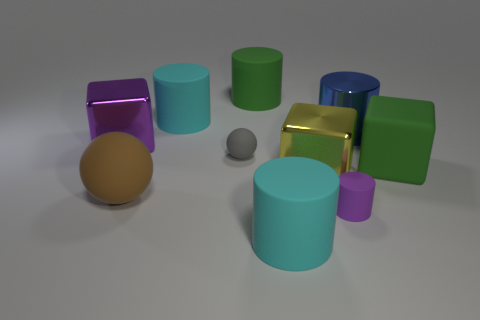Is there any other thing that is the same color as the rubber cube?
Keep it short and to the point. Yes. The purple thing in front of the large matte thing that is on the right side of the purple rubber thing is made of what material?
Provide a succinct answer. Rubber. Is the green cylinder made of the same material as the big blue cylinder behind the large yellow metallic thing?
Offer a terse response. No. How many objects are either big cyan things that are on the right side of the green rubber cylinder or big shiny cubes?
Keep it short and to the point. 3. Is there a big matte cylinder of the same color as the rubber block?
Your response must be concise. Yes. There is a yellow object; does it have the same shape as the big green object that is to the right of the big blue object?
Your response must be concise. Yes. How many things are both behind the small rubber cylinder and to the left of the large yellow shiny object?
Ensure brevity in your answer.  5. What is the material of the large purple thing that is the same shape as the large yellow object?
Offer a very short reply. Metal. How big is the purple shiny thing that is behind the big cyan object that is in front of the purple cylinder?
Give a very brief answer. Large. Is there a tiny green ball?
Keep it short and to the point. No. 